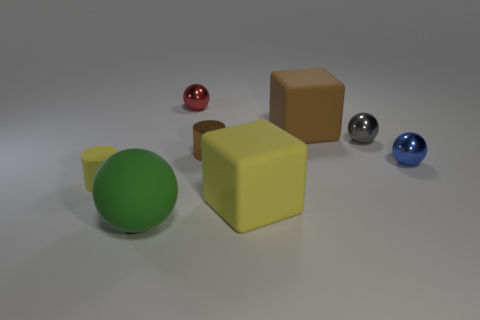How many tiny blue things are the same shape as the green object? Upon reviewing the image, there is one small blue sphere that has the same shape as the green object, which is spherical. No other items match the spherical shape in the given color. 